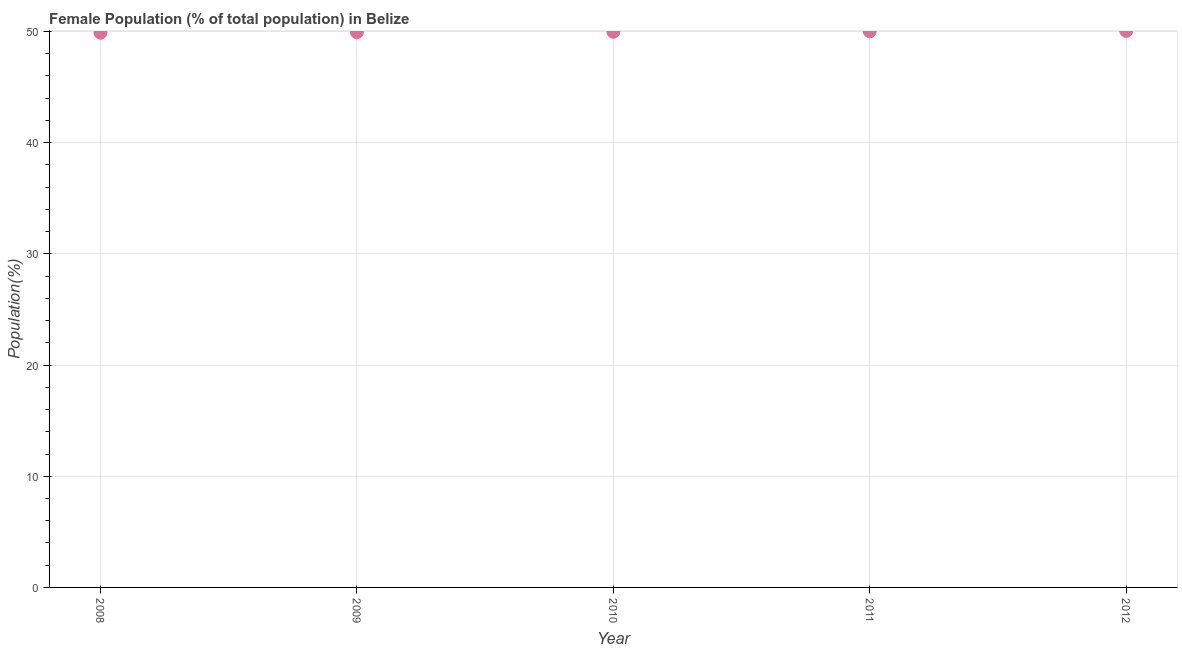What is the female population in 2010?
Offer a very short reply. 49.98. Across all years, what is the maximum female population?
Keep it short and to the point. 50.05. Across all years, what is the minimum female population?
Keep it short and to the point. 49.89. What is the sum of the female population?
Ensure brevity in your answer.  249.88. What is the difference between the female population in 2008 and 2010?
Offer a very short reply. -0.09. What is the average female population per year?
Provide a short and direct response. 49.98. What is the median female population?
Make the answer very short. 49.98. What is the ratio of the female population in 2009 to that in 2012?
Your response must be concise. 1. Is the female population in 2009 less than that in 2012?
Make the answer very short. Yes. Is the difference between the female population in 2010 and 2012 greater than the difference between any two years?
Keep it short and to the point. No. What is the difference between the highest and the second highest female population?
Keep it short and to the point. 0.04. Is the sum of the female population in 2008 and 2010 greater than the maximum female population across all years?
Your response must be concise. Yes. What is the difference between the highest and the lowest female population?
Keep it short and to the point. 0.16. In how many years, is the female population greater than the average female population taken over all years?
Ensure brevity in your answer.  3. How many years are there in the graph?
Your answer should be very brief. 5. Does the graph contain any zero values?
Offer a terse response. No. What is the title of the graph?
Provide a succinct answer. Female Population (% of total population) in Belize. What is the label or title of the X-axis?
Your answer should be very brief. Year. What is the label or title of the Y-axis?
Offer a terse response. Population(%). What is the Population(%) in 2008?
Offer a terse response. 49.89. What is the Population(%) in 2009?
Your answer should be compact. 49.94. What is the Population(%) in 2010?
Provide a succinct answer. 49.98. What is the Population(%) in 2011?
Ensure brevity in your answer.  50.02. What is the Population(%) in 2012?
Your answer should be compact. 50.05. What is the difference between the Population(%) in 2008 and 2009?
Ensure brevity in your answer.  -0.05. What is the difference between the Population(%) in 2008 and 2010?
Give a very brief answer. -0.09. What is the difference between the Population(%) in 2008 and 2011?
Your response must be concise. -0.13. What is the difference between the Population(%) in 2008 and 2012?
Make the answer very short. -0.16. What is the difference between the Population(%) in 2009 and 2010?
Offer a very short reply. -0.04. What is the difference between the Population(%) in 2009 and 2011?
Your answer should be compact. -0.08. What is the difference between the Population(%) in 2009 and 2012?
Your answer should be compact. -0.12. What is the difference between the Population(%) in 2010 and 2011?
Your response must be concise. -0.04. What is the difference between the Population(%) in 2010 and 2012?
Give a very brief answer. -0.07. What is the difference between the Population(%) in 2011 and 2012?
Provide a short and direct response. -0.04. What is the ratio of the Population(%) in 2008 to that in 2009?
Your response must be concise. 1. What is the ratio of the Population(%) in 2008 to that in 2012?
Keep it short and to the point. 1. What is the ratio of the Population(%) in 2009 to that in 2011?
Give a very brief answer. 1. What is the ratio of the Population(%) in 2009 to that in 2012?
Keep it short and to the point. 1. What is the ratio of the Population(%) in 2010 to that in 2011?
Keep it short and to the point. 1. What is the ratio of the Population(%) in 2010 to that in 2012?
Provide a short and direct response. 1. What is the ratio of the Population(%) in 2011 to that in 2012?
Your response must be concise. 1. 